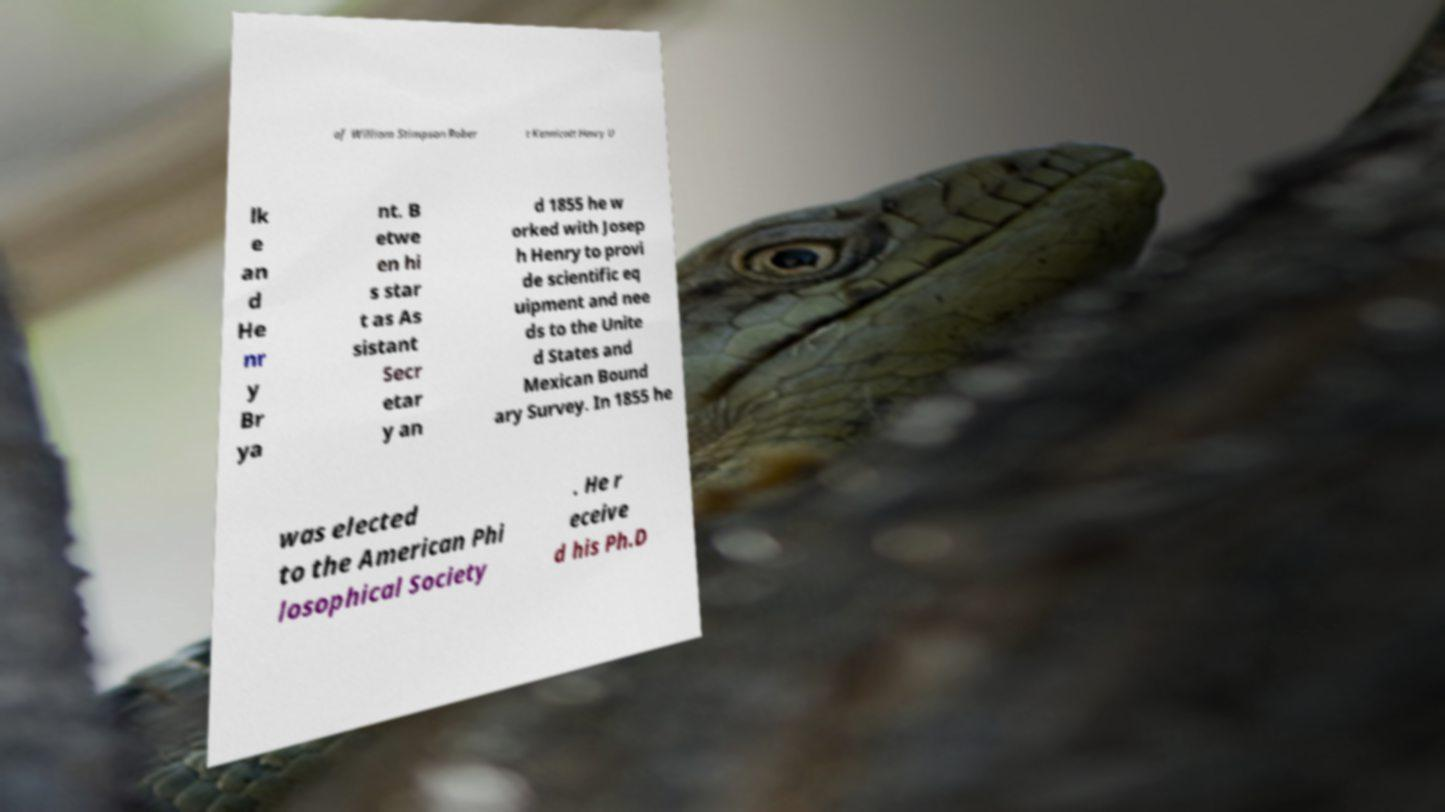What messages or text are displayed in this image? I need them in a readable, typed format. of William Stimpson Rober t Kennicott Henry U lk e an d He nr y Br ya nt. B etwe en hi s star t as As sistant Secr etar y an d 1855 he w orked with Josep h Henry to provi de scientific eq uipment and nee ds to the Unite d States and Mexican Bound ary Survey. In 1855 he was elected to the American Phi losophical Society . He r eceive d his Ph.D 